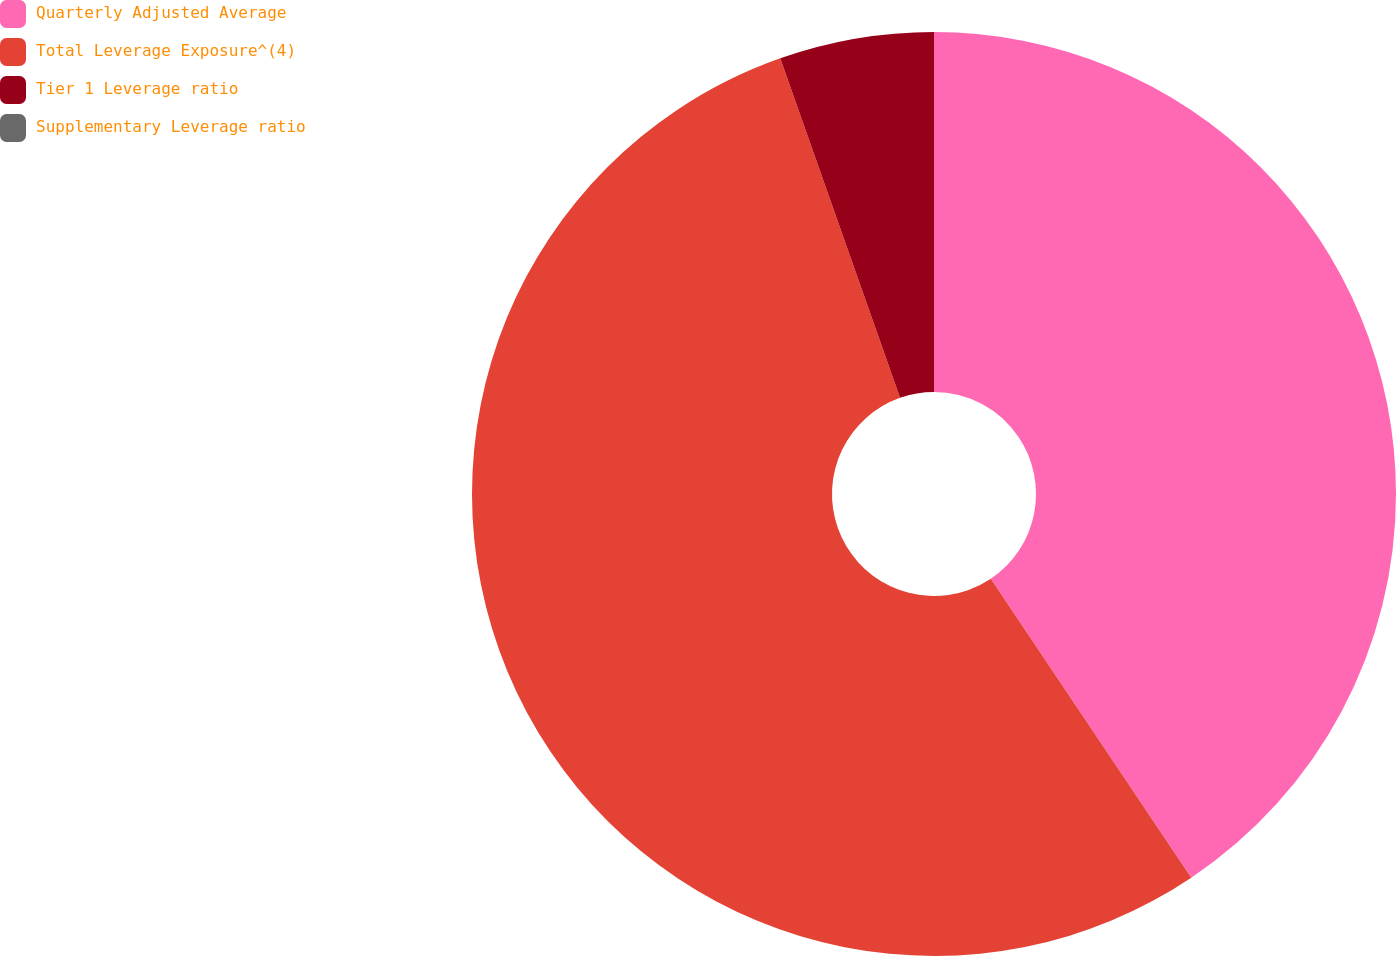<chart> <loc_0><loc_0><loc_500><loc_500><pie_chart><fcel>Quarterly Adjusted Average<fcel>Total Leverage Exposure^(4)<fcel>Tier 1 Leverage ratio<fcel>Supplementary Leverage ratio<nl><fcel>40.6%<fcel>54.0%<fcel>5.4%<fcel>0.0%<nl></chart> 